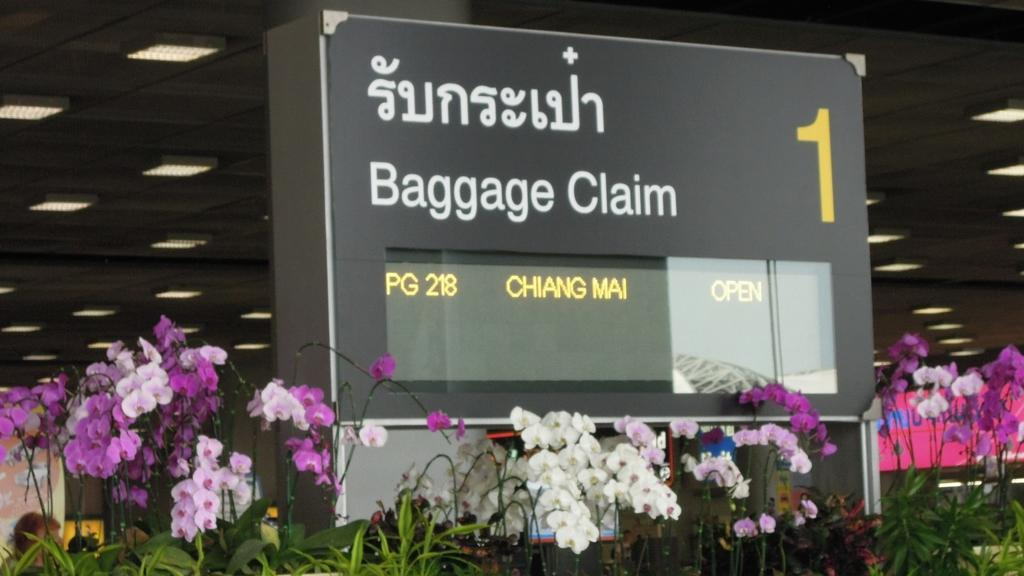What is the main object in the image? There is a name board in the image. What type of plants can be seen in the image? There are plants with flowers in the image. What can be used for illumination in the image? There are lights in the image. Can you describe any other objects present in the image? There are other objects present in the image, but their specific details are not mentioned in the provided facts. How many eggs are in the eggnog being served by the servant in the image? There is no servant or eggnog present in the image. Is the person driving the car in the image? There is no car or person driving in the image. 